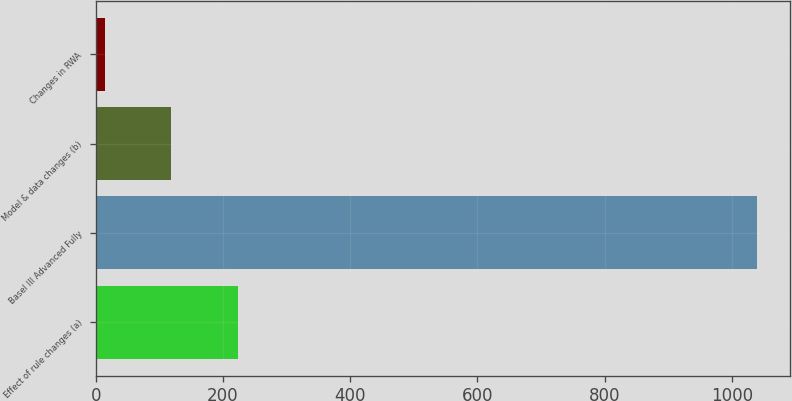<chart> <loc_0><loc_0><loc_500><loc_500><bar_chart><fcel>Effect of rule changes (a)<fcel>Basel III Advanced Fully<fcel>Model & data changes (b)<fcel>Changes in RWA<nl><fcel>223<fcel>1040<fcel>119<fcel>15<nl></chart> 